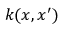Convert formula to latex. <formula><loc_0><loc_0><loc_500><loc_500>k ( x , x ^ { \prime } )</formula> 